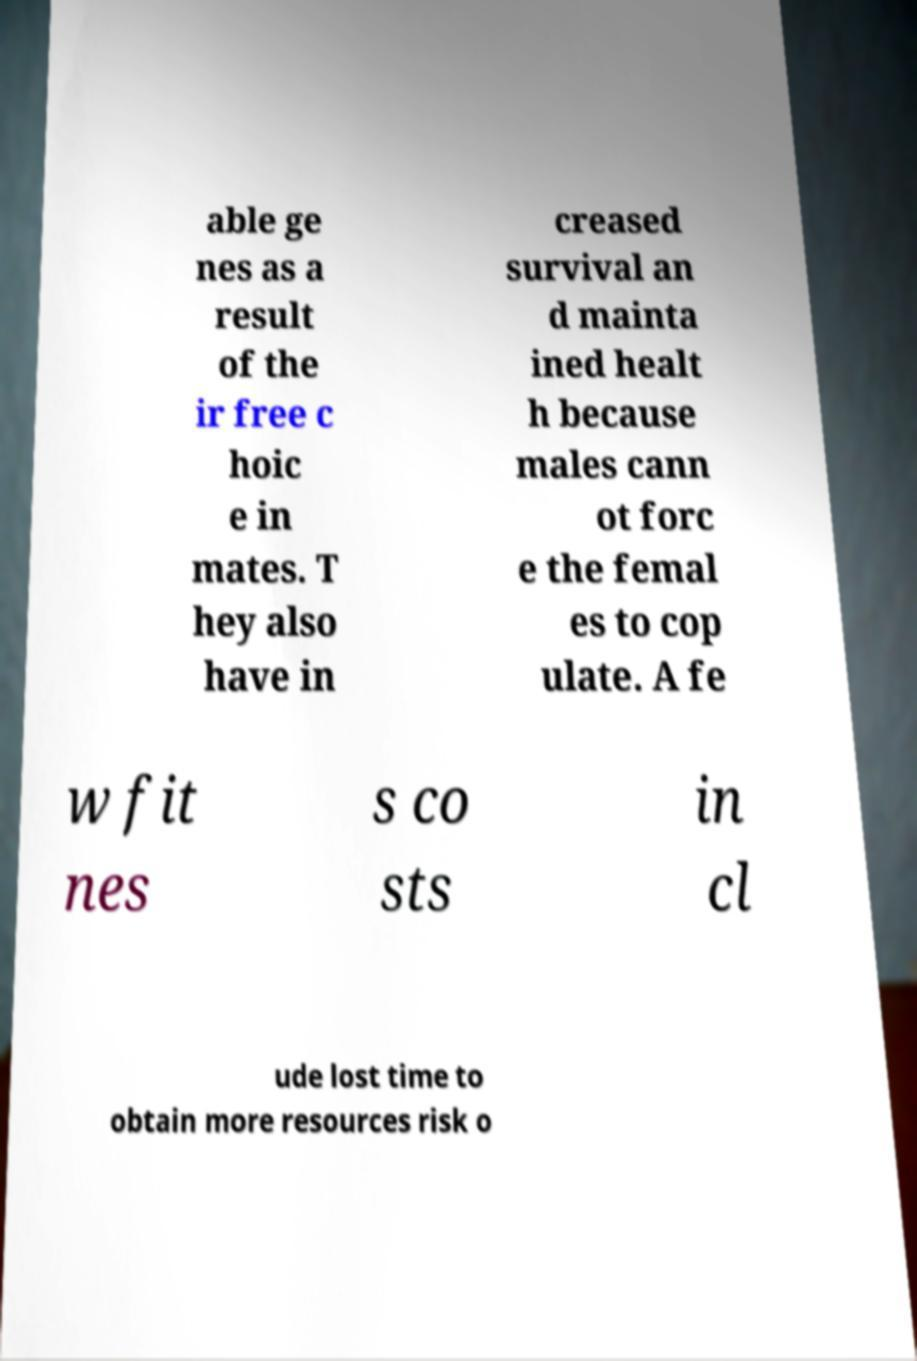Please identify and transcribe the text found in this image. able ge nes as a result of the ir free c hoic e in mates. T hey also have in creased survival an d mainta ined healt h because males cann ot forc e the femal es to cop ulate. A fe w fit nes s co sts in cl ude lost time to obtain more resources risk o 